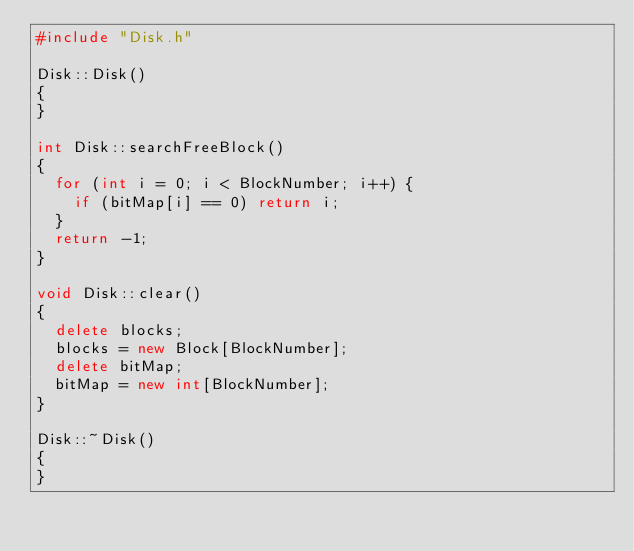Convert code to text. <code><loc_0><loc_0><loc_500><loc_500><_C++_>#include "Disk.h"

Disk::Disk()
{
}

int Disk::searchFreeBlock()
{
	for (int i = 0; i < BlockNumber; i++) {
		if (bitMap[i] == 0) return i;
	}
	return -1;
}

void Disk::clear()
{
	delete blocks;
	blocks = new Block[BlockNumber];
	delete bitMap;
	bitMap = new int[BlockNumber];
}

Disk::~Disk()
{
}</code> 